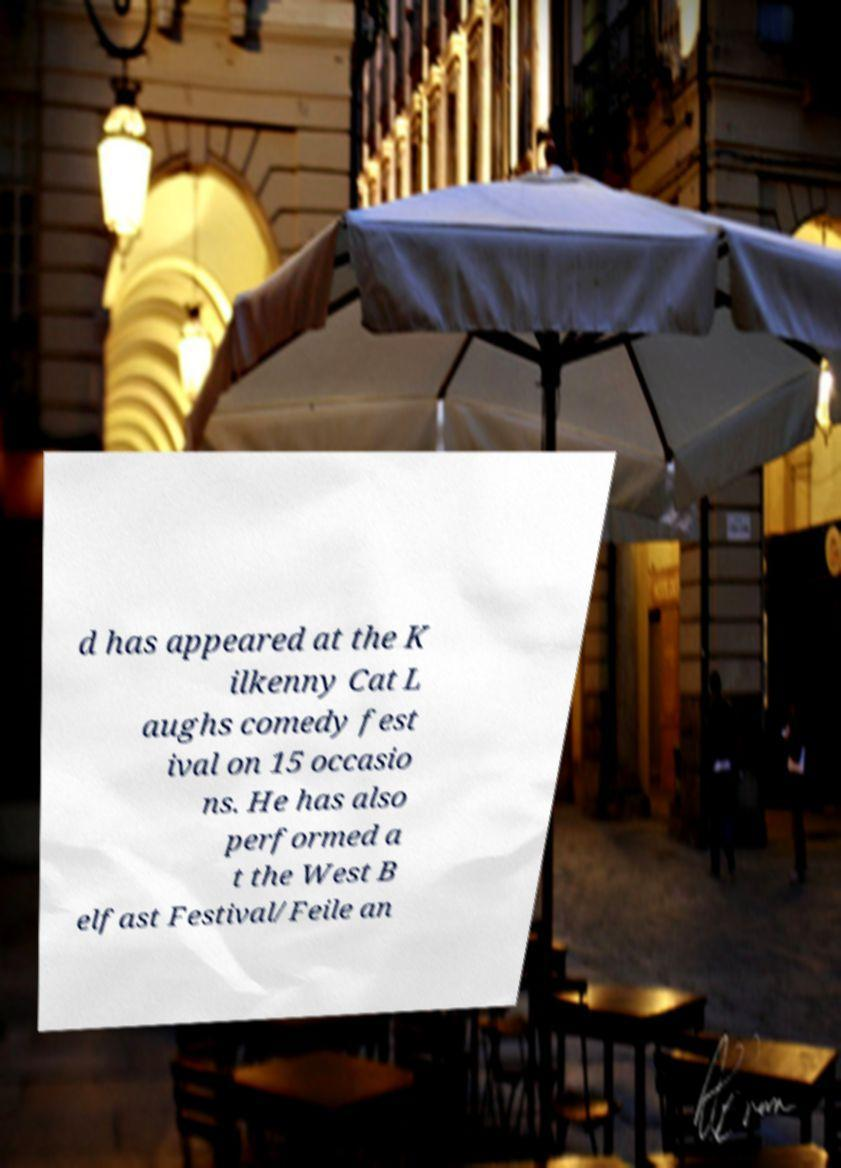Could you assist in decoding the text presented in this image and type it out clearly? d has appeared at the K ilkenny Cat L aughs comedy fest ival on 15 occasio ns. He has also performed a t the West B elfast Festival/Feile an 